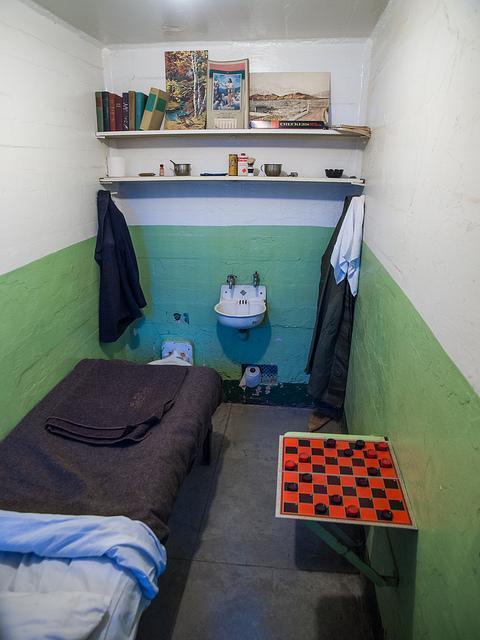Who most likely sleeps here?
Select the accurate response from the four choices given to answer the question.
Options: Prisoner, grandmother, baby, landscaper. Prisoner. 